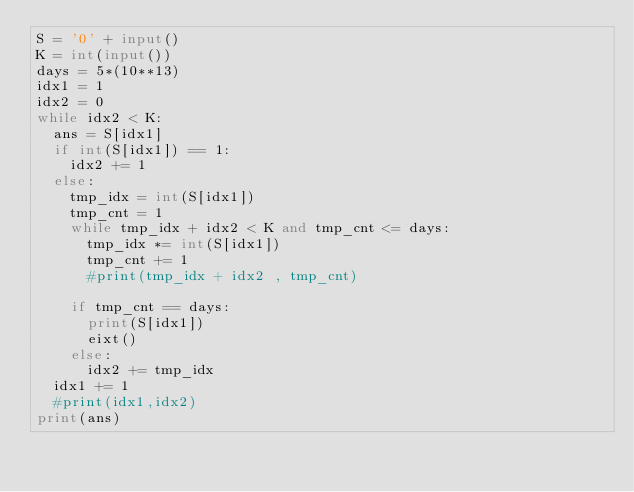Convert code to text. <code><loc_0><loc_0><loc_500><loc_500><_Python_>S = '0' + input()
K = int(input())
days = 5*(10**13)
idx1 = 1
idx2 = 0
while idx2 < K:
  ans = S[idx1]
  if int(S[idx1]) == 1:
    idx2 += 1
  else:
    tmp_idx = int(S[idx1])
    tmp_cnt = 1 
    while tmp_idx + idx2 < K and tmp_cnt <= days:
      tmp_idx *= int(S[idx1])
      tmp_cnt += 1
      #print(tmp_idx + idx2 , tmp_cnt)
    
    if tmp_cnt == days:
      print(S[idx1])
      eixt()
    else:
      idx2 += tmp_idx
  idx1 += 1
  #print(idx1,idx2)
print(ans)</code> 